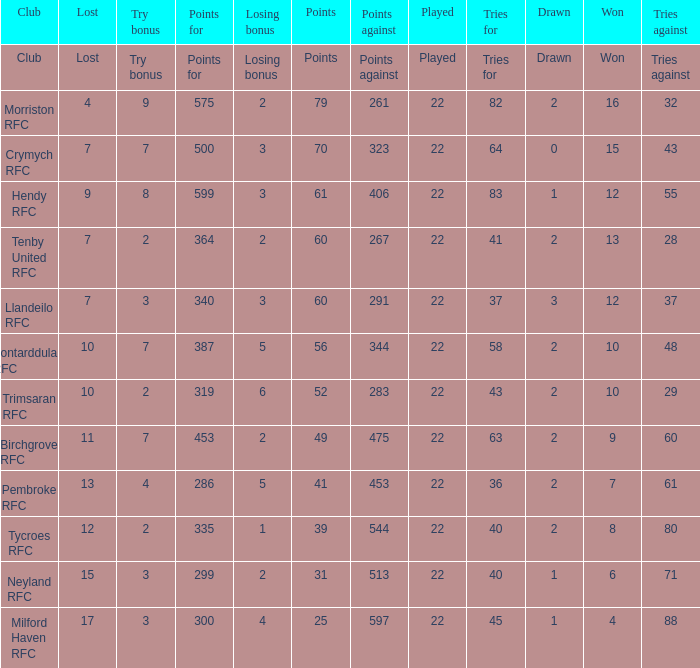What's the won with try bonus being 8 12.0. 